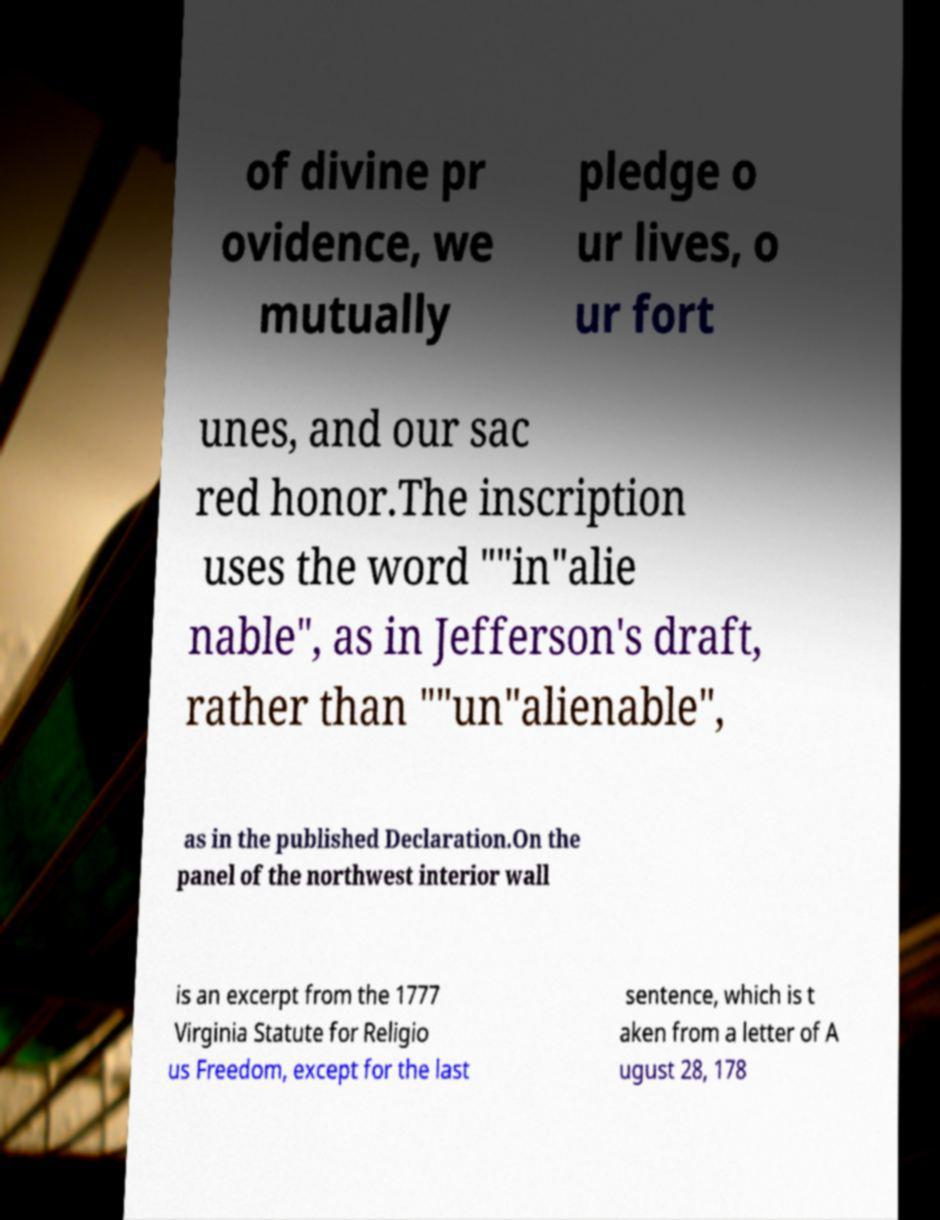Please identify and transcribe the text found in this image. of divine pr ovidence, we mutually pledge o ur lives, o ur fort unes, and our sac red honor.The inscription uses the word ""in"alie nable", as in Jefferson's draft, rather than ""un"alienable", as in the published Declaration.On the panel of the northwest interior wall is an excerpt from the 1777 Virginia Statute for Religio us Freedom, except for the last sentence, which is t aken from a letter of A ugust 28, 178 